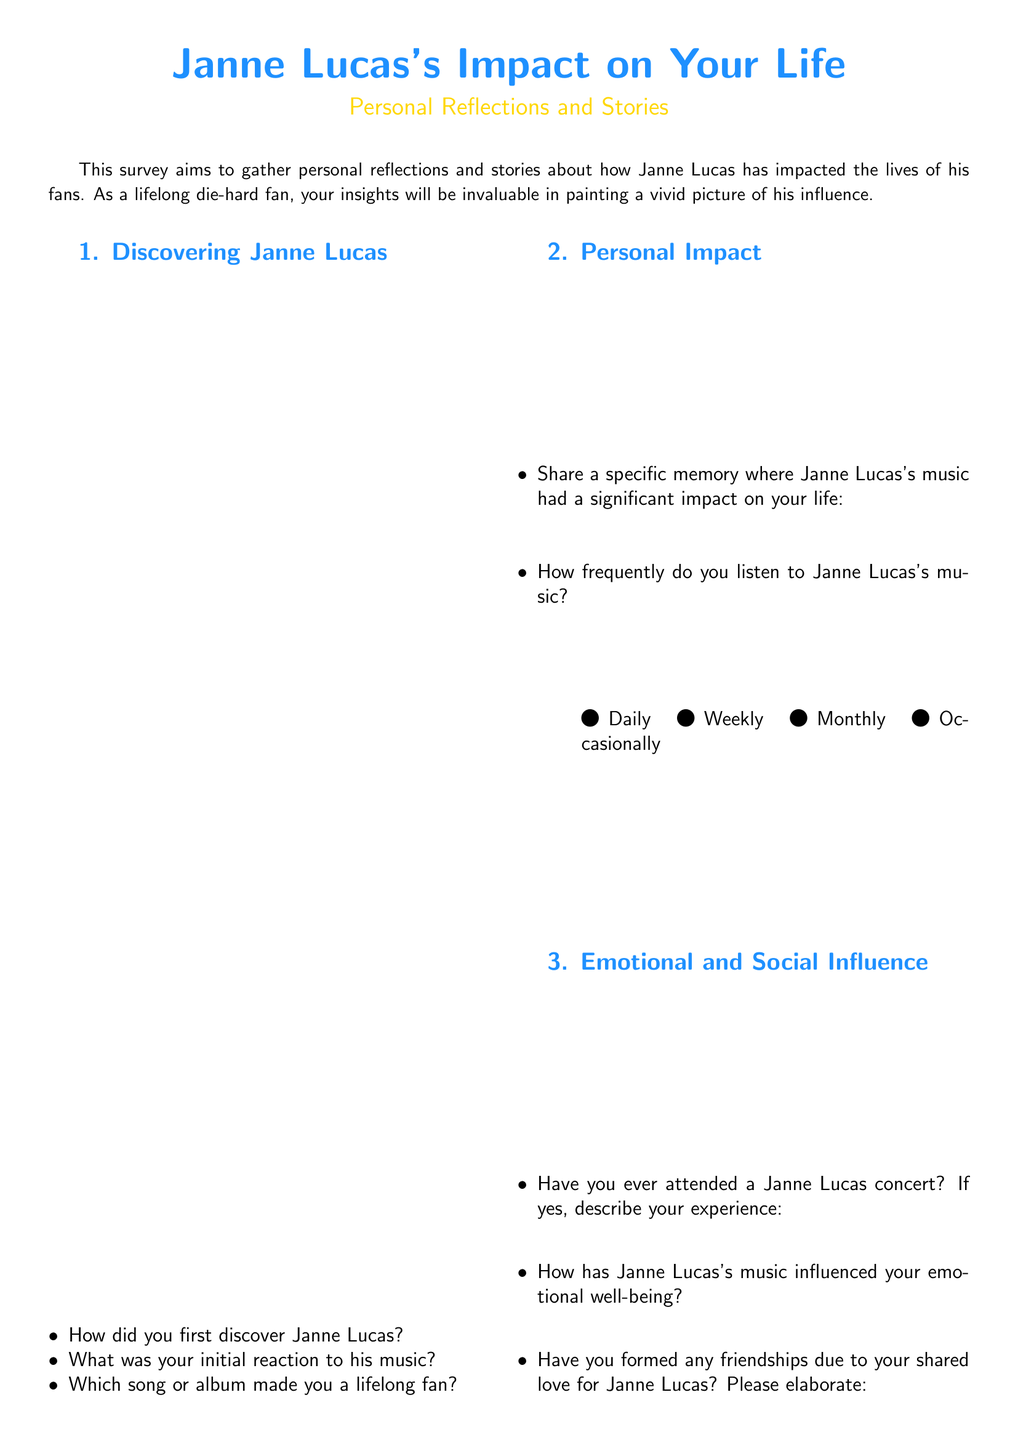How did you first discover Janne Lucas? This is a direct question from the survey requesting personal experiences regarding the discovery of Janne Lucas.
Answer: Open-ended response What was your initial reaction to his music? This question seeks to understand the respondent's first emotional response to Janne Lucas's music as mentioned in the survey.
Answer: Open-ended response How frequently do you listen to Janne Lucas's music? This question offers several options in the survey for the frequency of listening, requiring a selection.
Answer: Daily, Weekly, Monthly, Occasionally Which era of Janne Lucas's music do you prefer the most? The survey asks for a selection regarding the era of music the respondent enjoys, with multiple-choice options.
Answer: 1970s, 1980s, 1990s, 2000s and beyond Have you ever attended a Janne Lucas concert? This question is directed at experiences related to attending concerts, a direct inquiry from the survey.
Answer: Yes or No What is your all-time favorite Janne Lucas song or album and why? This question aims to solicit a personal favorite from the respondent, asking for a specific title and reason.
Answer: Open-ended response Have you formed any friendships due to your shared love for Janne Lucas? The survey inquires about the social impact of Janne Lucas's music, noting if any friendships were formed.
Answer: Open-ended response What is your favorite memorabilia or autograph? This question requests details about any cherished items related to Janne Lucas, reflecting the survey's focus on personal connections.
Answer: Open-ended response How has Janne Lucas's music influenced your emotional well-being? This question aims to understand the emotional effects of the music, as mentioned in the personal reflections section of the survey.
Answer: Open-ended response 